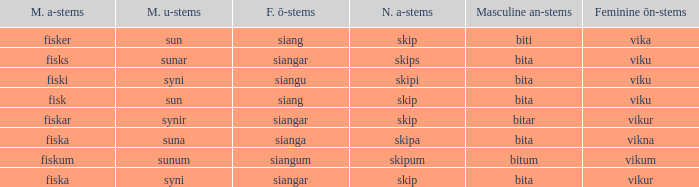What ending does siangu get for ön? Viku. 